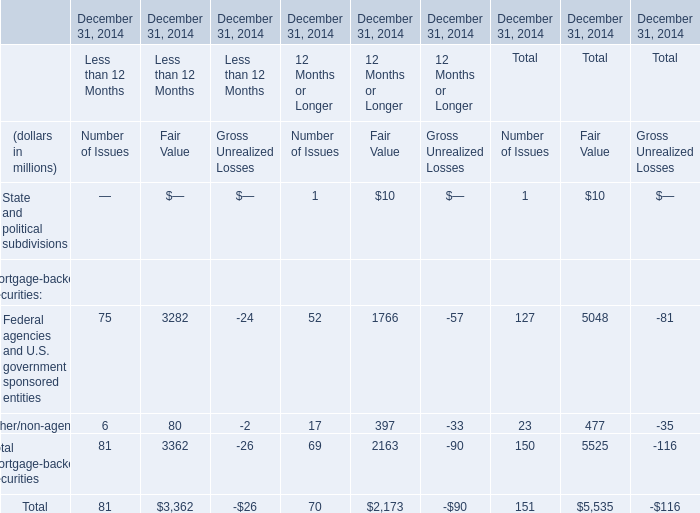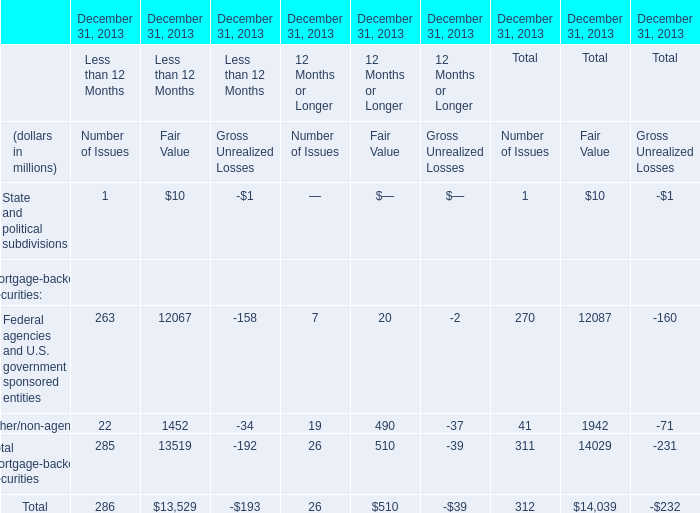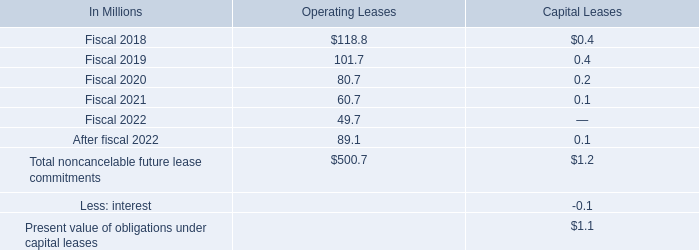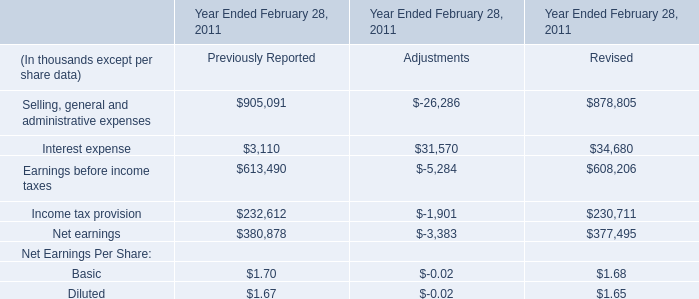in 2016 what was the ratio of the net benefit recognized to the accrued interest and penalties 
Computations: (2.7 / 32.1)
Answer: 0.08411. 